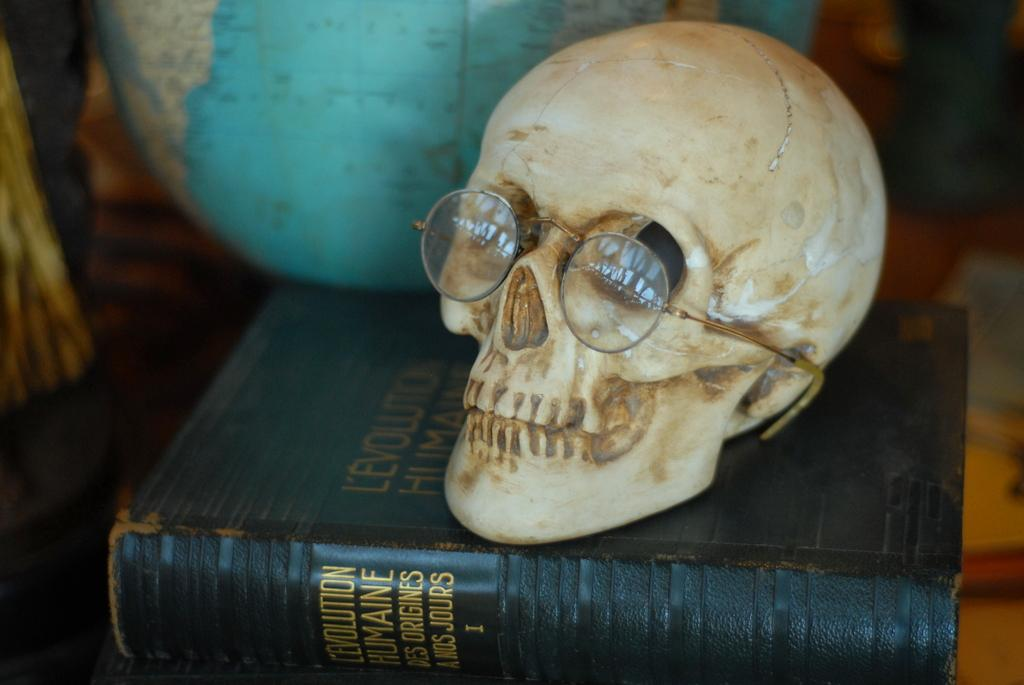What is the main subject of the image? The main subject of the image is a white skull with specs. What is the skull placed on? The skull is placed on a black book. What can be seen in the background of the image? There is a blue globe visible in the background of the image. What type of wilderness can be seen in the image? There is no wilderness present in the image; it features a white skull with specs placed on a black book, with a blue globe visible in the background. What instrument is the stranger playing in the image? There is no stranger or instrument present in the image. 